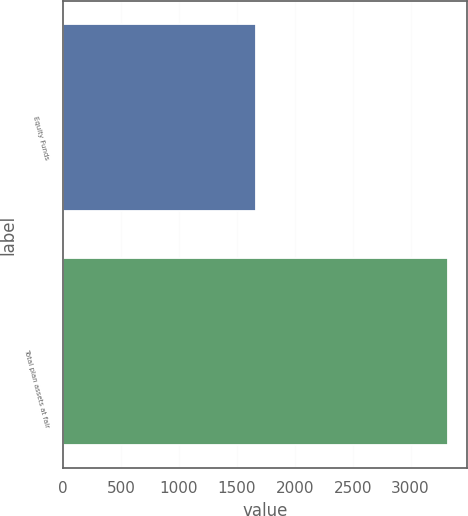Convert chart. <chart><loc_0><loc_0><loc_500><loc_500><bar_chart><fcel>Equity Funds<fcel>Total plan assets at fair<nl><fcel>1665<fcel>3320<nl></chart> 